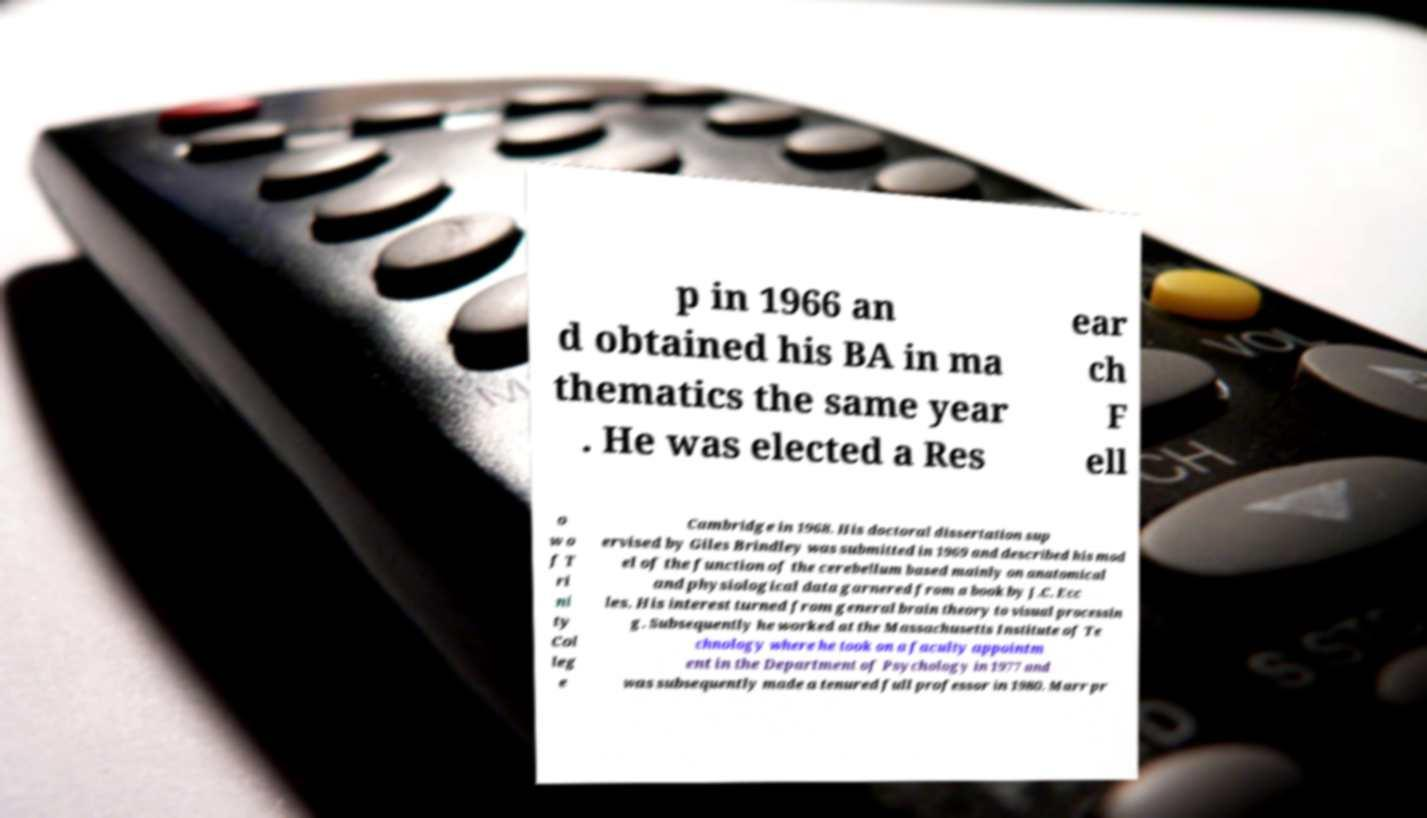Could you extract and type out the text from this image? p in 1966 an d obtained his BA in ma thematics the same year . He was elected a Res ear ch F ell o w o f T ri ni ty Col leg e Cambridge in 1968. His doctoral dissertation sup ervised by Giles Brindley was submitted in 1969 and described his mod el of the function of the cerebellum based mainly on anatomical and physiological data garnered from a book by J.C. Ecc les. His interest turned from general brain theory to visual processin g. Subsequently he worked at the Massachusetts Institute of Te chnology where he took on a faculty appointm ent in the Department of Psychology in 1977 and was subsequently made a tenured full professor in 1980. Marr pr 